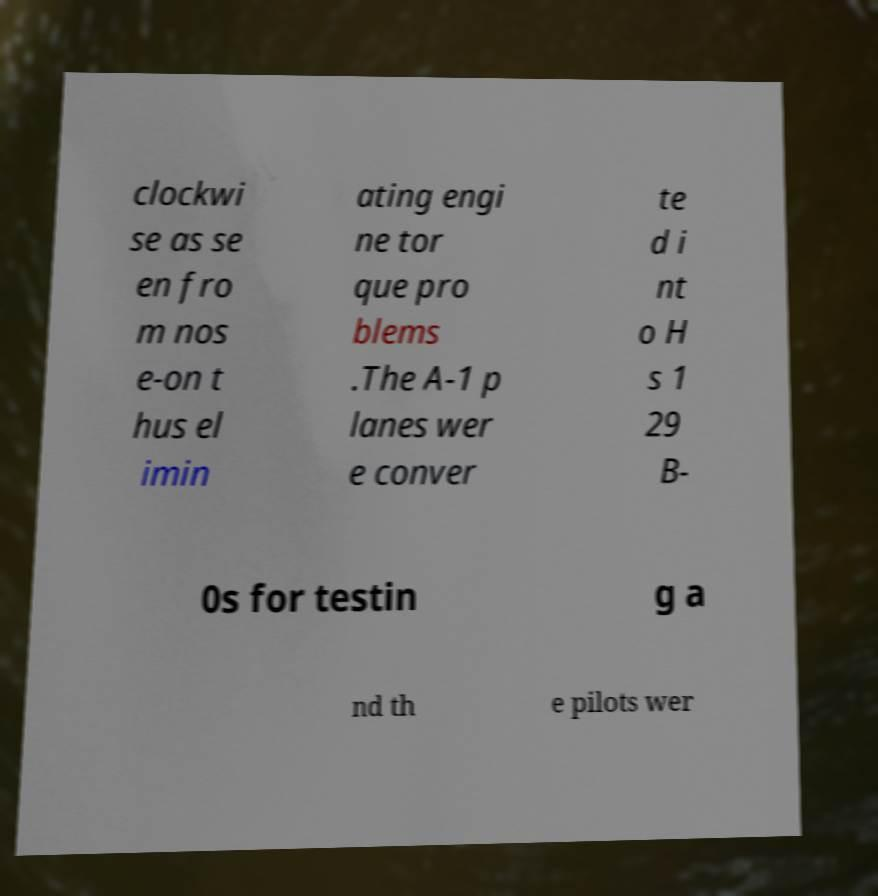I need the written content from this picture converted into text. Can you do that? clockwi se as se en fro m nos e-on t hus el imin ating engi ne tor que pro blems .The A-1 p lanes wer e conver te d i nt o H s 1 29 B- 0s for testin g a nd th e pilots wer 